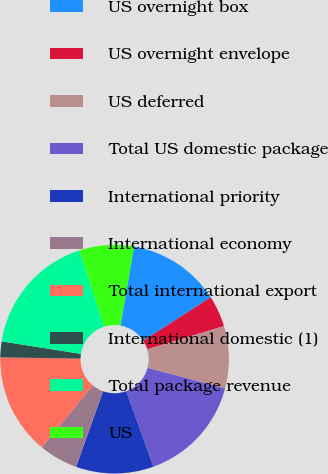<chart> <loc_0><loc_0><loc_500><loc_500><pie_chart><fcel>US overnight box<fcel>US overnight envelope<fcel>US deferred<fcel>Total US domestic package<fcel>International priority<fcel>International economy<fcel>Total international export<fcel>International domestic (1)<fcel>Total package revenue<fcel>US<nl><fcel>13.17%<fcel>4.43%<fcel>8.8%<fcel>15.36%<fcel>10.98%<fcel>5.52%<fcel>14.26%<fcel>2.24%<fcel>17.54%<fcel>7.7%<nl></chart> 